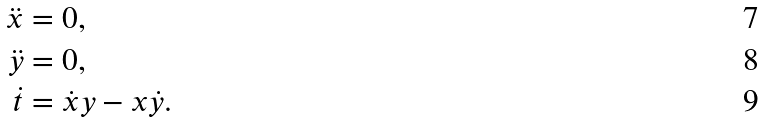Convert formula to latex. <formula><loc_0><loc_0><loc_500><loc_500>\ddot { x } & = 0 , \\ \ddot { y } & = 0 , \\ \dot { t } & = \dot { x } y - x \dot { y } .</formula> 